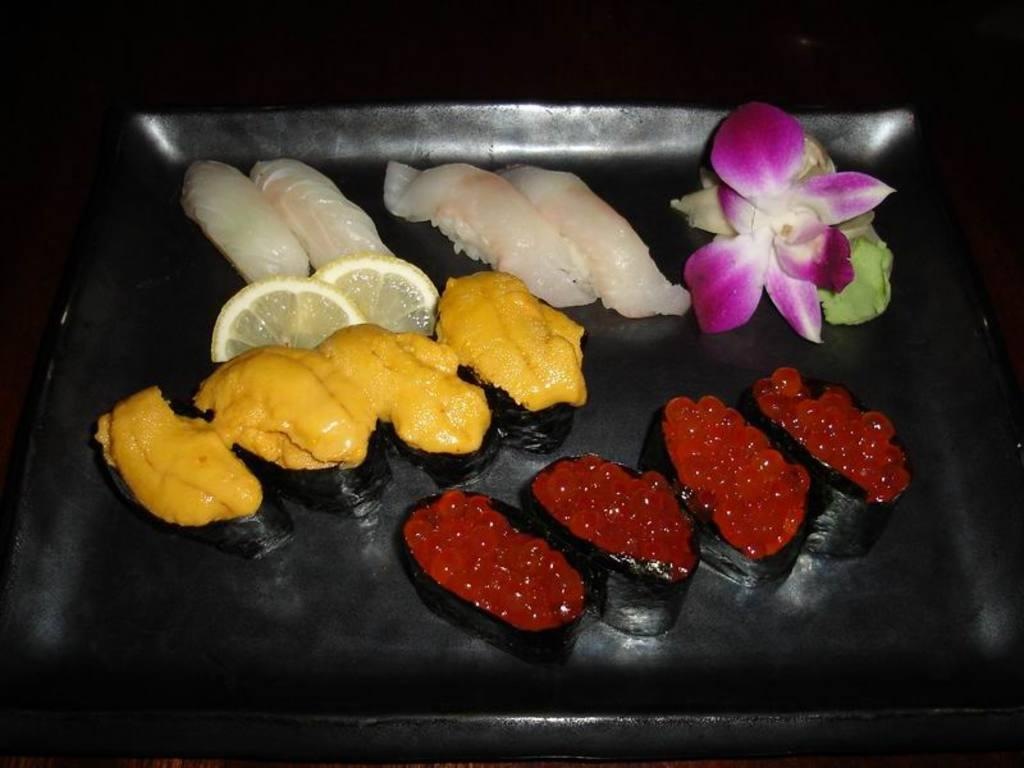What types of items can be seen in the image? There are food items in the image. Can you describe a specific object in the image? There is a flower in a black color object in the image. How much money is visible in the image? There is no money visible in the image; it only contains food items and a flower in a black color object. 